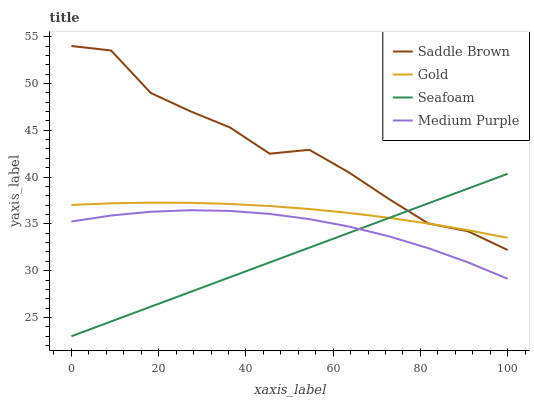Does Seafoam have the minimum area under the curve?
Answer yes or no. Yes. Does Saddle Brown have the maximum area under the curve?
Answer yes or no. Yes. Does Gold have the minimum area under the curve?
Answer yes or no. No. Does Gold have the maximum area under the curve?
Answer yes or no. No. Is Seafoam the smoothest?
Answer yes or no. Yes. Is Saddle Brown the roughest?
Answer yes or no. Yes. Is Gold the smoothest?
Answer yes or no. No. Is Gold the roughest?
Answer yes or no. No. Does Seafoam have the lowest value?
Answer yes or no. Yes. Does Saddle Brown have the lowest value?
Answer yes or no. No. Does Saddle Brown have the highest value?
Answer yes or no. Yes. Does Gold have the highest value?
Answer yes or no. No. Is Medium Purple less than Gold?
Answer yes or no. Yes. Is Gold greater than Medium Purple?
Answer yes or no. Yes. Does Medium Purple intersect Seafoam?
Answer yes or no. Yes. Is Medium Purple less than Seafoam?
Answer yes or no. No. Is Medium Purple greater than Seafoam?
Answer yes or no. No. Does Medium Purple intersect Gold?
Answer yes or no. No. 